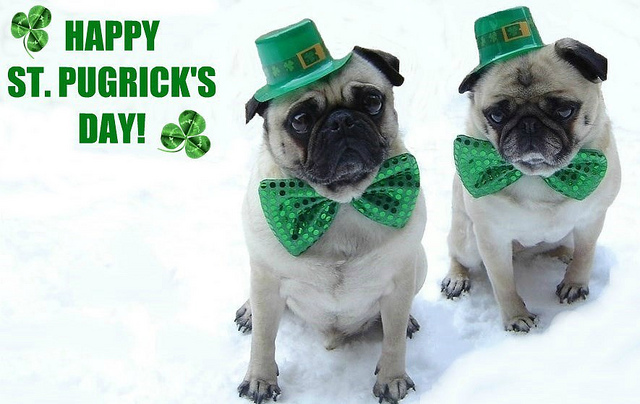Read all the text in this image. HAPPY ST. PUGRICK'S DAY 